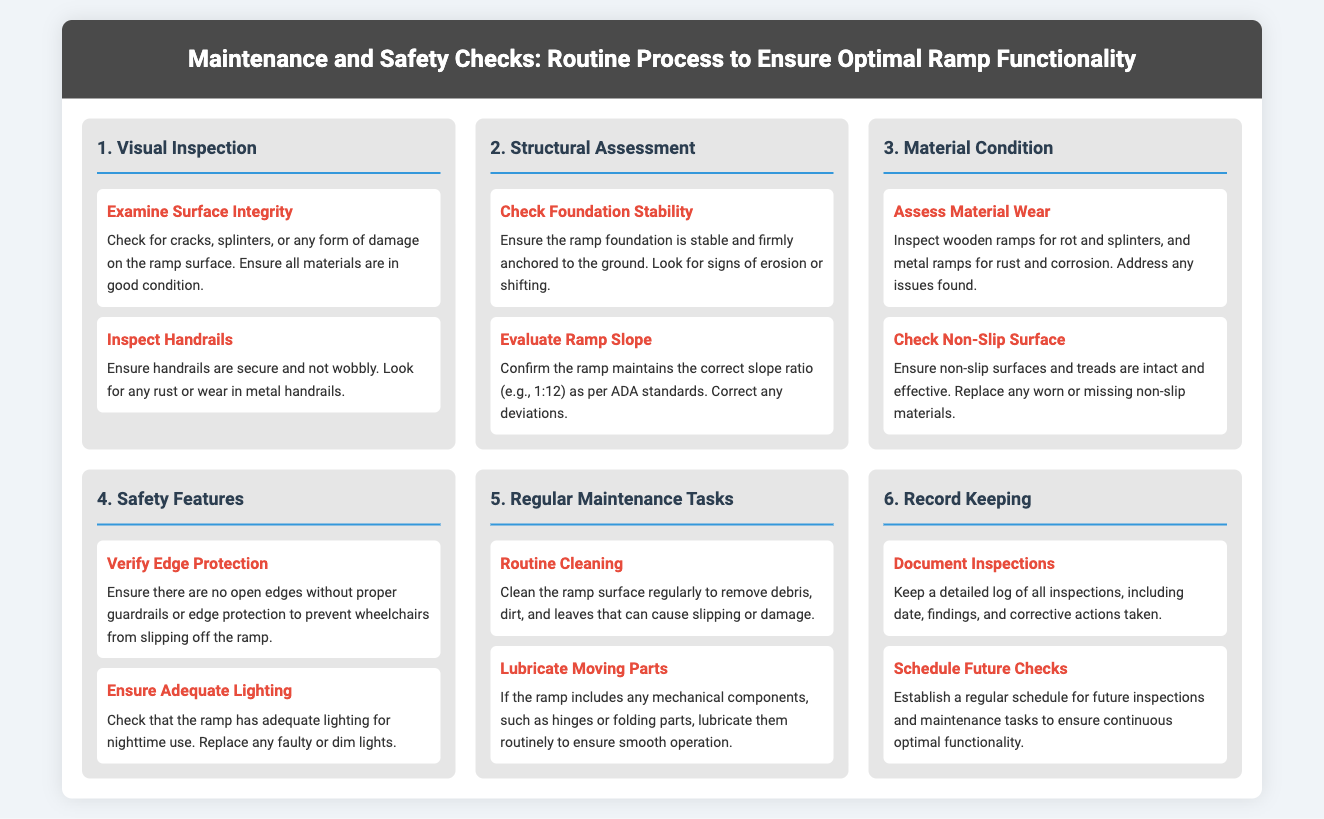What is the title of the document? The title is prominently displayed at the top of the document.
Answer: Maintenance and Safety Checks: Routine Process to Ensure Optimal Ramp Functionality How many main sections are there in the document? The document outlines a total of six main sections focused on different aspects of ramp maintenance.
Answer: 6 What should you check for in a ramp's handrails? The document specifies what to look for when inspecting handrails.
Answer: Secure and not wobbly What slope ratio is recommended for ramps as per ADA standards? The document explicitly mentions the slope ratio that should be maintained for compliance.
Answer: 1:12 What type of maintenance task involves cleaning the ramp surface? The document categorizes the tasks required for maintaining ramp functionality, one of which is cleaning.
Answer: Routine Cleaning What should be documented during inspections? The document stresses the importance of keeping track of inspection details.
Answer: Inspections, date, findings, actions taken What lighting condition should be ensured for ramps? The document indicates the lighting requirement that is essential for ramp safety.
Answer: Adequate lighting Which feature prevents wheelchairs from slipping off the ramp? The document lists safety features that are important for ramp safety, including edge protection.
Answer: Edge Protection 